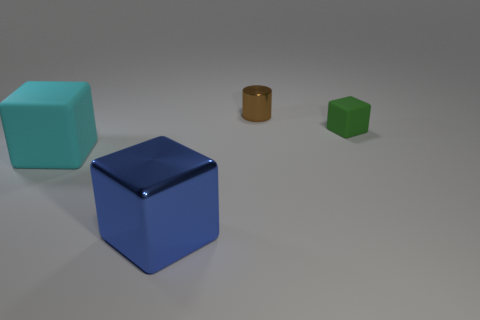Is there anything else that is the same shape as the blue shiny object?
Make the answer very short. Yes. There is a tiny brown cylinder; what number of small shiny cylinders are behind it?
Offer a very short reply. 0. Are there the same number of things that are behind the cylinder and metal things?
Offer a very short reply. No. Are the brown object and the big blue cube made of the same material?
Provide a short and direct response. Yes. There is a object that is to the left of the small metallic thing and to the right of the cyan matte block; how big is it?
Give a very brief answer. Large. What number of blue metal objects have the same size as the cyan rubber object?
Provide a succinct answer. 1. There is a matte block in front of the cube that is on the right side of the brown metal cylinder; what size is it?
Ensure brevity in your answer.  Large. There is a matte object that is in front of the green object; is it the same shape as the thing to the right of the brown cylinder?
Ensure brevity in your answer.  Yes. There is a cube that is on the right side of the large cyan object and on the left side of the small green object; what color is it?
Make the answer very short. Blue. Is there a tiny cube of the same color as the cylinder?
Make the answer very short. No. 